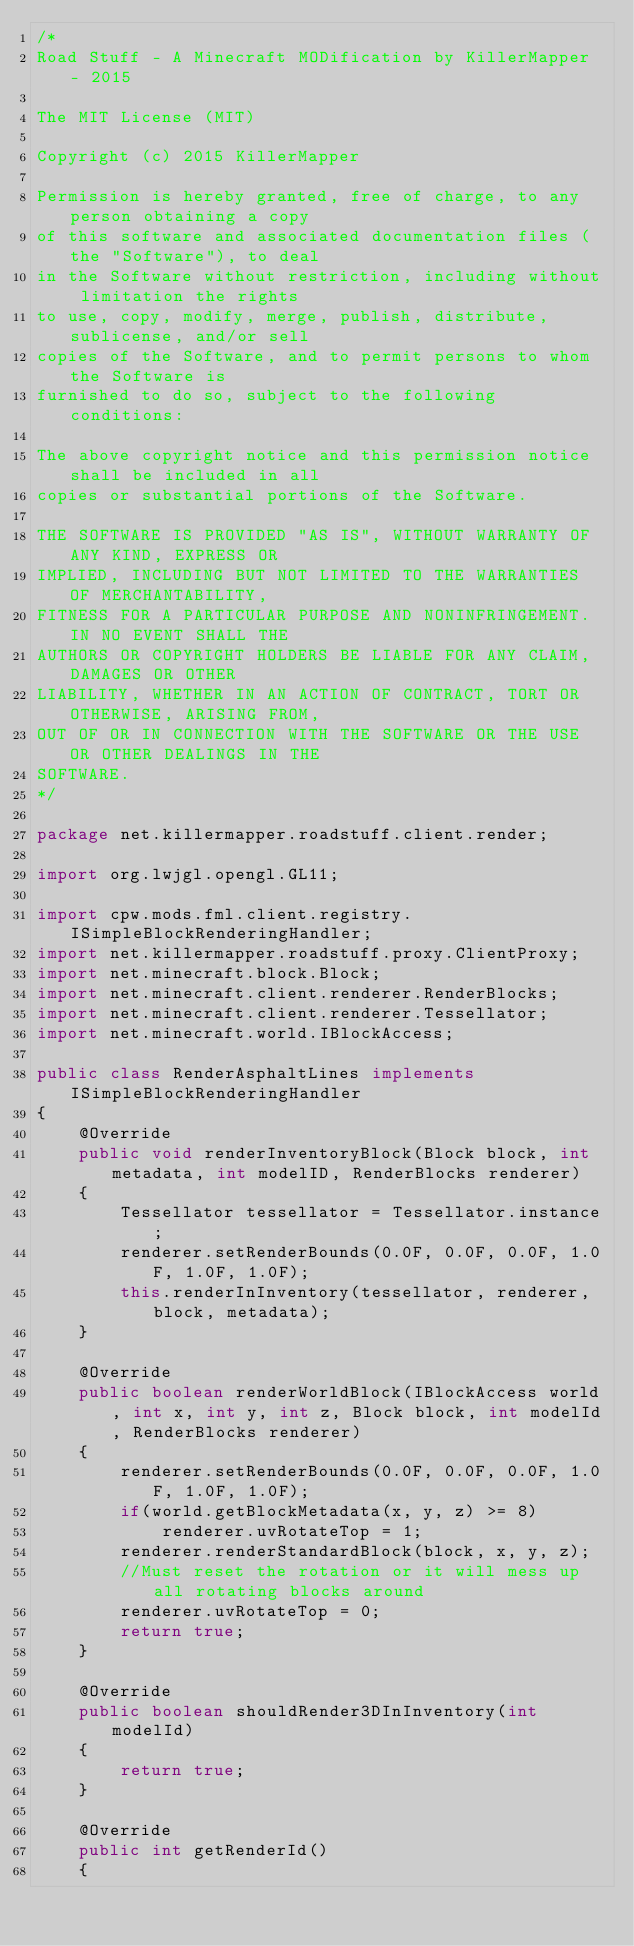<code> <loc_0><loc_0><loc_500><loc_500><_Java_>/*
Road Stuff - A Minecraft MODification by KillerMapper - 2015

The MIT License (MIT)

Copyright (c) 2015 KillerMapper

Permission is hereby granted, free of charge, to any person obtaining a copy
of this software and associated documentation files (the "Software"), to deal
in the Software without restriction, including without limitation the rights
to use, copy, modify, merge, publish, distribute, sublicense, and/or sell
copies of the Software, and to permit persons to whom the Software is
furnished to do so, subject to the following conditions:

The above copyright notice and this permission notice shall be included in all
copies or substantial portions of the Software.

THE SOFTWARE IS PROVIDED "AS IS", WITHOUT WARRANTY OF ANY KIND, EXPRESS OR
IMPLIED, INCLUDING BUT NOT LIMITED TO THE WARRANTIES OF MERCHANTABILITY,
FITNESS FOR A PARTICULAR PURPOSE AND NONINFRINGEMENT. IN NO EVENT SHALL THE
AUTHORS OR COPYRIGHT HOLDERS BE LIABLE FOR ANY CLAIM, DAMAGES OR OTHER
LIABILITY, WHETHER IN AN ACTION OF CONTRACT, TORT OR OTHERWISE, ARISING FROM,
OUT OF OR IN CONNECTION WITH THE SOFTWARE OR THE USE OR OTHER DEALINGS IN THE
SOFTWARE.
*/

package net.killermapper.roadstuff.client.render;

import org.lwjgl.opengl.GL11;

import cpw.mods.fml.client.registry.ISimpleBlockRenderingHandler;
import net.killermapper.roadstuff.proxy.ClientProxy;
import net.minecraft.block.Block;
import net.minecraft.client.renderer.RenderBlocks;
import net.minecraft.client.renderer.Tessellator;
import net.minecraft.world.IBlockAccess;

public class RenderAsphaltLines implements ISimpleBlockRenderingHandler
{
	@Override
	public void renderInventoryBlock(Block block, int metadata, int modelID, RenderBlocks renderer)
	{
		Tessellator tessellator = Tessellator.instance;
		renderer.setRenderBounds(0.0F, 0.0F, 0.0F, 1.0F, 1.0F, 1.0F);
		this.renderInInventory(tessellator, renderer, block, metadata);
	}

	@Override
	public boolean renderWorldBlock(IBlockAccess world, int x, int y, int z, Block block, int modelId, RenderBlocks renderer)
	{
		renderer.setRenderBounds(0.0F, 0.0F, 0.0F, 1.0F, 1.0F, 1.0F);
		if(world.getBlockMetadata(x, y, z) >= 8)
			renderer.uvRotateTop = 1;
		renderer.renderStandardBlock(block, x, y, z);
		//Must reset the rotation or it will mess up all rotating blocks around
		renderer.uvRotateTop = 0;
		return true;
	}
	
	@Override
	public boolean shouldRender3DInInventory(int modelId)
	{
		return true;
	}

	@Override
	public int getRenderId()
	{</code> 